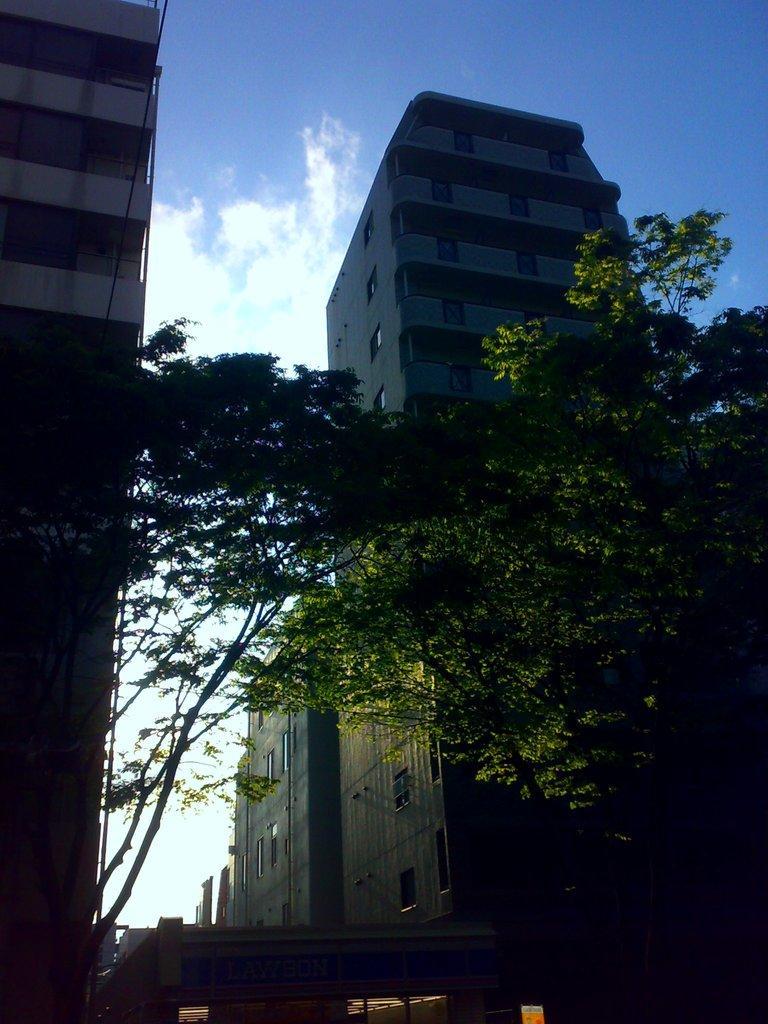In one or two sentences, can you explain what this image depicts? In this image I can see few plants which are green in color, few buildings and I can see a vehicle on the ground. In the background I can see the sky. 